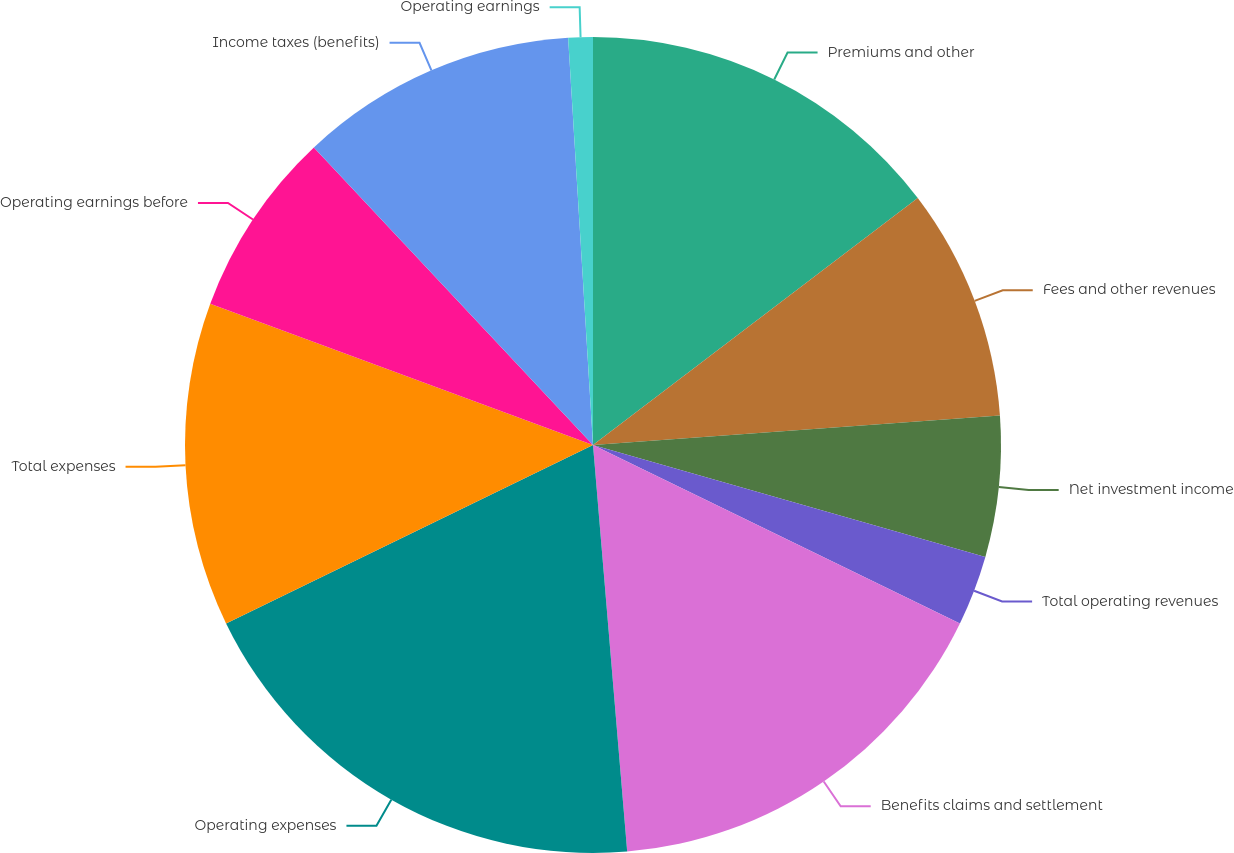Convert chart to OTSL. <chart><loc_0><loc_0><loc_500><loc_500><pie_chart><fcel>Premiums and other<fcel>Fees and other revenues<fcel>Net investment income<fcel>Total operating revenues<fcel>Benefits claims and settlement<fcel>Operating expenses<fcel>Total expenses<fcel>Operating earnings before<fcel>Income taxes (benefits)<fcel>Operating earnings<nl><fcel>14.65%<fcel>9.2%<fcel>5.57%<fcel>2.78%<fcel>16.46%<fcel>19.13%<fcel>12.83%<fcel>7.38%<fcel>11.02%<fcel>0.97%<nl></chart> 